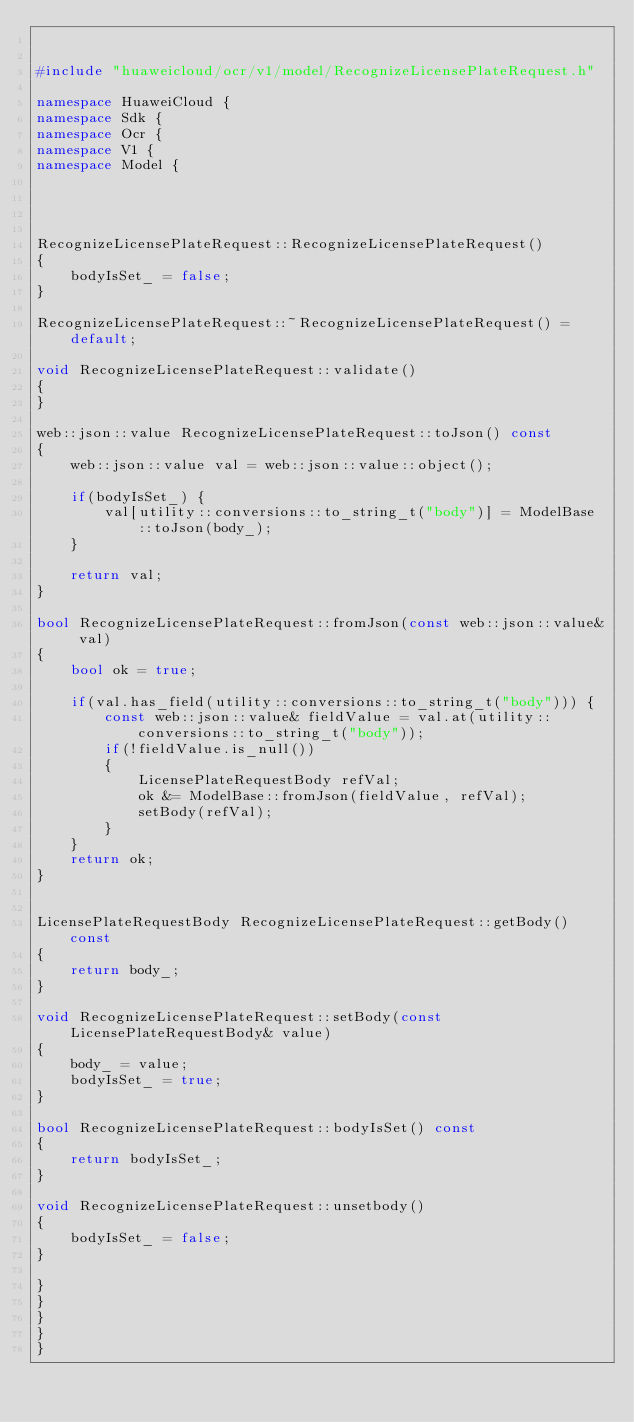Convert code to text. <code><loc_0><loc_0><loc_500><loc_500><_C++_>

#include "huaweicloud/ocr/v1/model/RecognizeLicensePlateRequest.h"

namespace HuaweiCloud {
namespace Sdk {
namespace Ocr {
namespace V1 {
namespace Model {




RecognizeLicensePlateRequest::RecognizeLicensePlateRequest()
{
    bodyIsSet_ = false;
}

RecognizeLicensePlateRequest::~RecognizeLicensePlateRequest() = default;

void RecognizeLicensePlateRequest::validate()
{
}

web::json::value RecognizeLicensePlateRequest::toJson() const
{
    web::json::value val = web::json::value::object();

    if(bodyIsSet_) {
        val[utility::conversions::to_string_t("body")] = ModelBase::toJson(body_);
    }

    return val;
}

bool RecognizeLicensePlateRequest::fromJson(const web::json::value& val)
{
    bool ok = true;
    
    if(val.has_field(utility::conversions::to_string_t("body"))) {
        const web::json::value& fieldValue = val.at(utility::conversions::to_string_t("body"));
        if(!fieldValue.is_null())
        {
            LicensePlateRequestBody refVal;
            ok &= ModelBase::fromJson(fieldValue, refVal);
            setBody(refVal);
        }
    }
    return ok;
}


LicensePlateRequestBody RecognizeLicensePlateRequest::getBody() const
{
    return body_;
}

void RecognizeLicensePlateRequest::setBody(const LicensePlateRequestBody& value)
{
    body_ = value;
    bodyIsSet_ = true;
}

bool RecognizeLicensePlateRequest::bodyIsSet() const
{
    return bodyIsSet_;
}

void RecognizeLicensePlateRequest::unsetbody()
{
    bodyIsSet_ = false;
}

}
}
}
}
}


</code> 